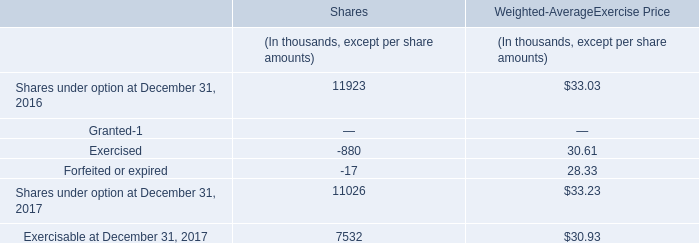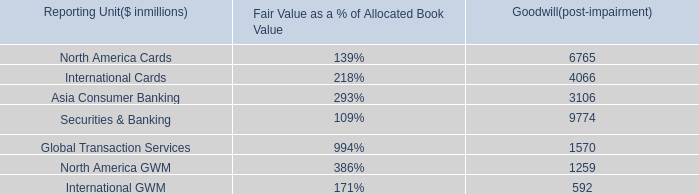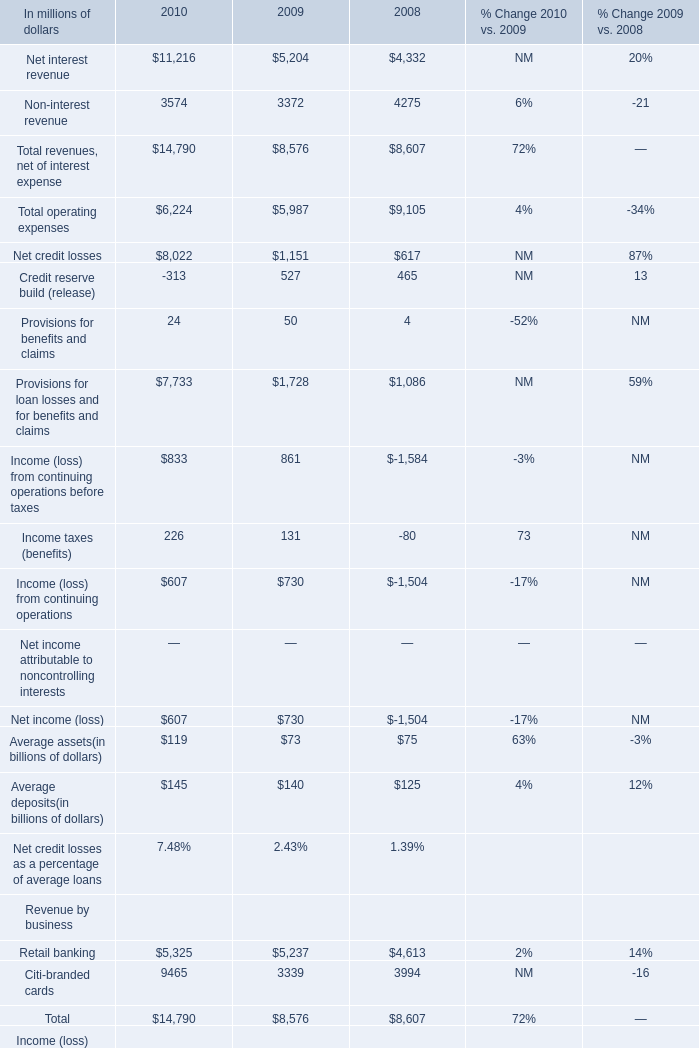What's the growth rate of Net interest revenue in 2010? 
Computations: ((11216 - 5204) / 5204)
Answer: 1.15527. 